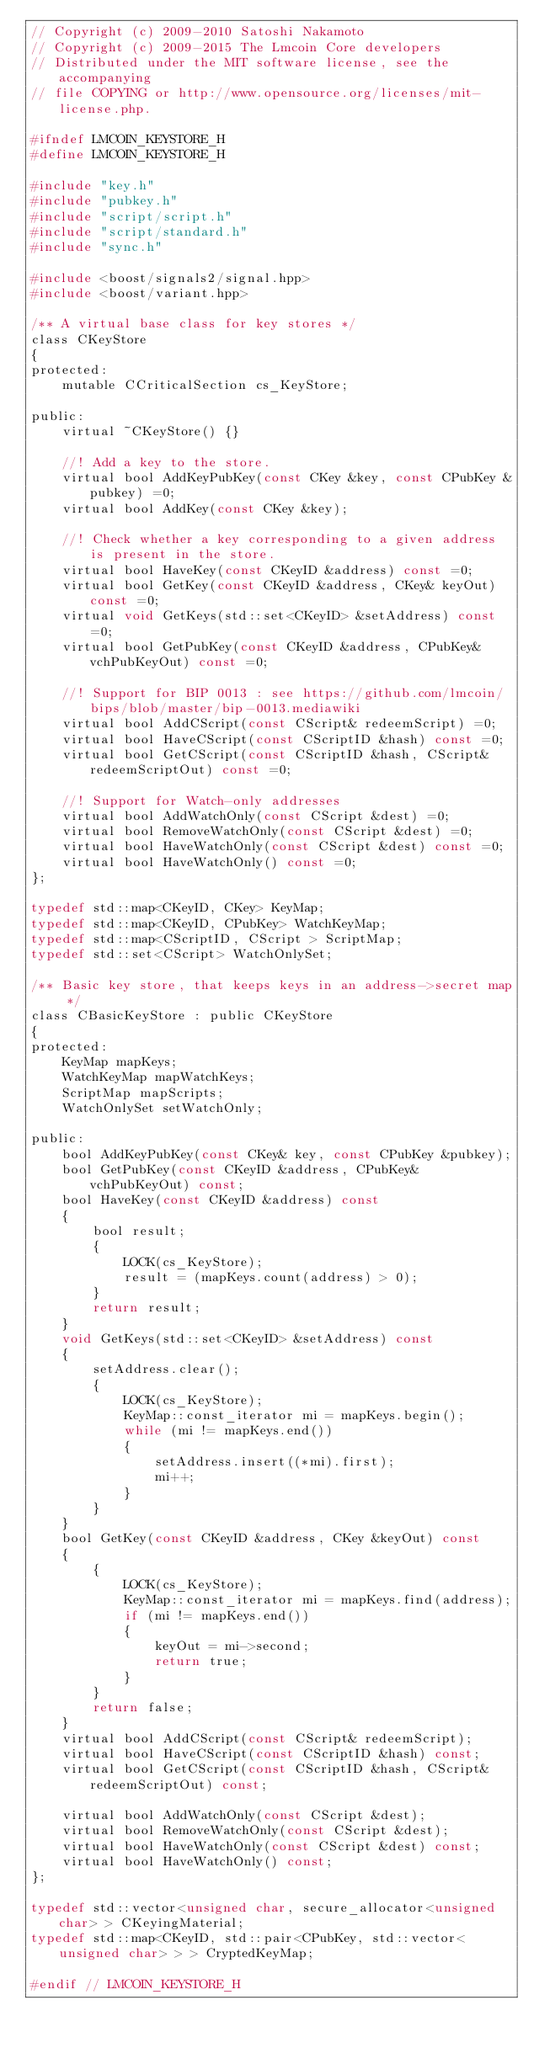Convert code to text. <code><loc_0><loc_0><loc_500><loc_500><_C_>// Copyright (c) 2009-2010 Satoshi Nakamoto
// Copyright (c) 2009-2015 The Lmcoin Core developers
// Distributed under the MIT software license, see the accompanying
// file COPYING or http://www.opensource.org/licenses/mit-license.php.

#ifndef LMCOIN_KEYSTORE_H
#define LMCOIN_KEYSTORE_H

#include "key.h"
#include "pubkey.h"
#include "script/script.h"
#include "script/standard.h"
#include "sync.h"

#include <boost/signals2/signal.hpp>
#include <boost/variant.hpp>

/** A virtual base class for key stores */
class CKeyStore
{
protected:
    mutable CCriticalSection cs_KeyStore;

public:
    virtual ~CKeyStore() {}

    //! Add a key to the store.
    virtual bool AddKeyPubKey(const CKey &key, const CPubKey &pubkey) =0;
    virtual bool AddKey(const CKey &key);

    //! Check whether a key corresponding to a given address is present in the store.
    virtual bool HaveKey(const CKeyID &address) const =0;
    virtual bool GetKey(const CKeyID &address, CKey& keyOut) const =0;
    virtual void GetKeys(std::set<CKeyID> &setAddress) const =0;
    virtual bool GetPubKey(const CKeyID &address, CPubKey& vchPubKeyOut) const =0;

    //! Support for BIP 0013 : see https://github.com/lmcoin/bips/blob/master/bip-0013.mediawiki
    virtual bool AddCScript(const CScript& redeemScript) =0;
    virtual bool HaveCScript(const CScriptID &hash) const =0;
    virtual bool GetCScript(const CScriptID &hash, CScript& redeemScriptOut) const =0;

    //! Support for Watch-only addresses
    virtual bool AddWatchOnly(const CScript &dest) =0;
    virtual bool RemoveWatchOnly(const CScript &dest) =0;
    virtual bool HaveWatchOnly(const CScript &dest) const =0;
    virtual bool HaveWatchOnly() const =0;
};

typedef std::map<CKeyID, CKey> KeyMap;
typedef std::map<CKeyID, CPubKey> WatchKeyMap;
typedef std::map<CScriptID, CScript > ScriptMap;
typedef std::set<CScript> WatchOnlySet;

/** Basic key store, that keeps keys in an address->secret map */
class CBasicKeyStore : public CKeyStore
{
protected:
    KeyMap mapKeys;
    WatchKeyMap mapWatchKeys;
    ScriptMap mapScripts;
    WatchOnlySet setWatchOnly;

public:
    bool AddKeyPubKey(const CKey& key, const CPubKey &pubkey);
    bool GetPubKey(const CKeyID &address, CPubKey& vchPubKeyOut) const;
    bool HaveKey(const CKeyID &address) const
    {
        bool result;
        {
            LOCK(cs_KeyStore);
            result = (mapKeys.count(address) > 0);
        }
        return result;
    }
    void GetKeys(std::set<CKeyID> &setAddress) const
    {
        setAddress.clear();
        {
            LOCK(cs_KeyStore);
            KeyMap::const_iterator mi = mapKeys.begin();
            while (mi != mapKeys.end())
            {
                setAddress.insert((*mi).first);
                mi++;
            }
        }
    }
    bool GetKey(const CKeyID &address, CKey &keyOut) const
    {
        {
            LOCK(cs_KeyStore);
            KeyMap::const_iterator mi = mapKeys.find(address);
            if (mi != mapKeys.end())
            {
                keyOut = mi->second;
                return true;
            }
        }
        return false;
    }
    virtual bool AddCScript(const CScript& redeemScript);
    virtual bool HaveCScript(const CScriptID &hash) const;
    virtual bool GetCScript(const CScriptID &hash, CScript& redeemScriptOut) const;

    virtual bool AddWatchOnly(const CScript &dest);
    virtual bool RemoveWatchOnly(const CScript &dest);
    virtual bool HaveWatchOnly(const CScript &dest) const;
    virtual bool HaveWatchOnly() const;
};

typedef std::vector<unsigned char, secure_allocator<unsigned char> > CKeyingMaterial;
typedef std::map<CKeyID, std::pair<CPubKey, std::vector<unsigned char> > > CryptedKeyMap;

#endif // LMCOIN_KEYSTORE_H
</code> 